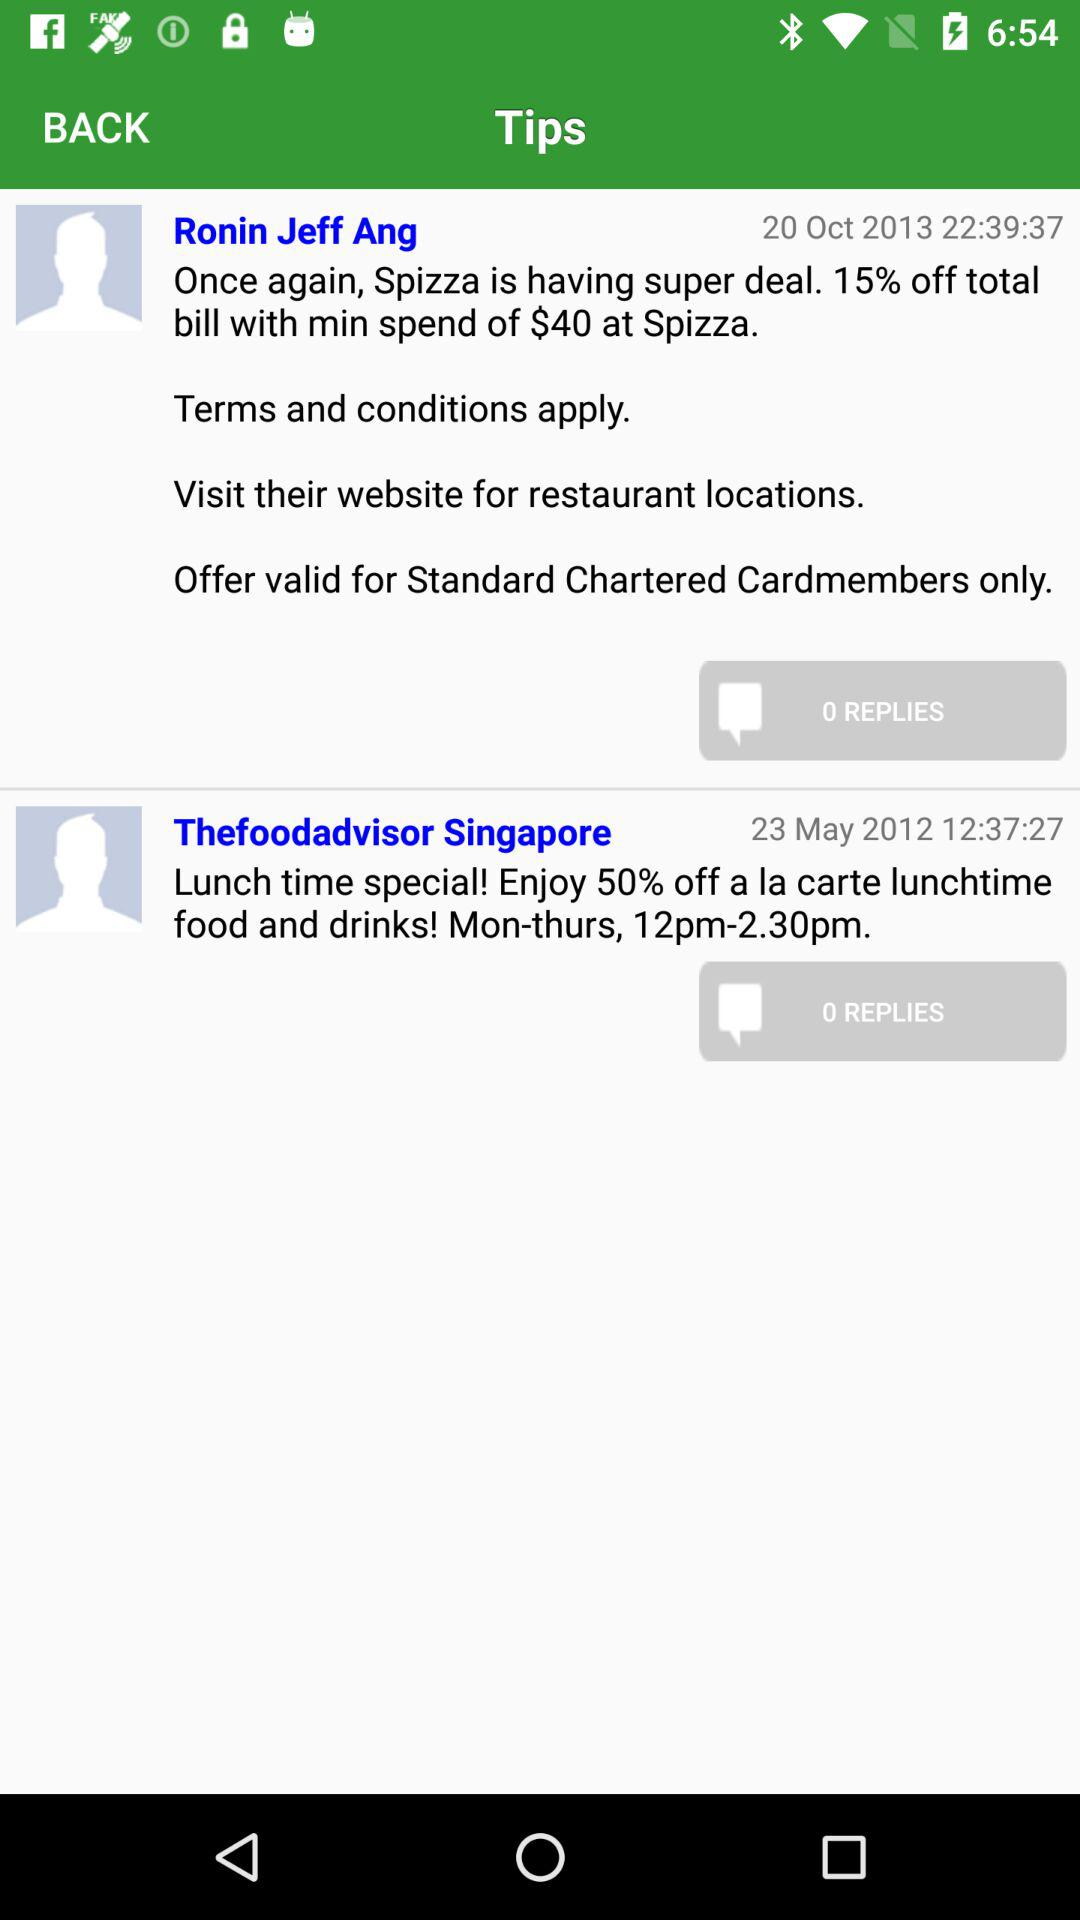What is the user name who posted on October 20th? The user name is "Ronin Jeff Ang". 